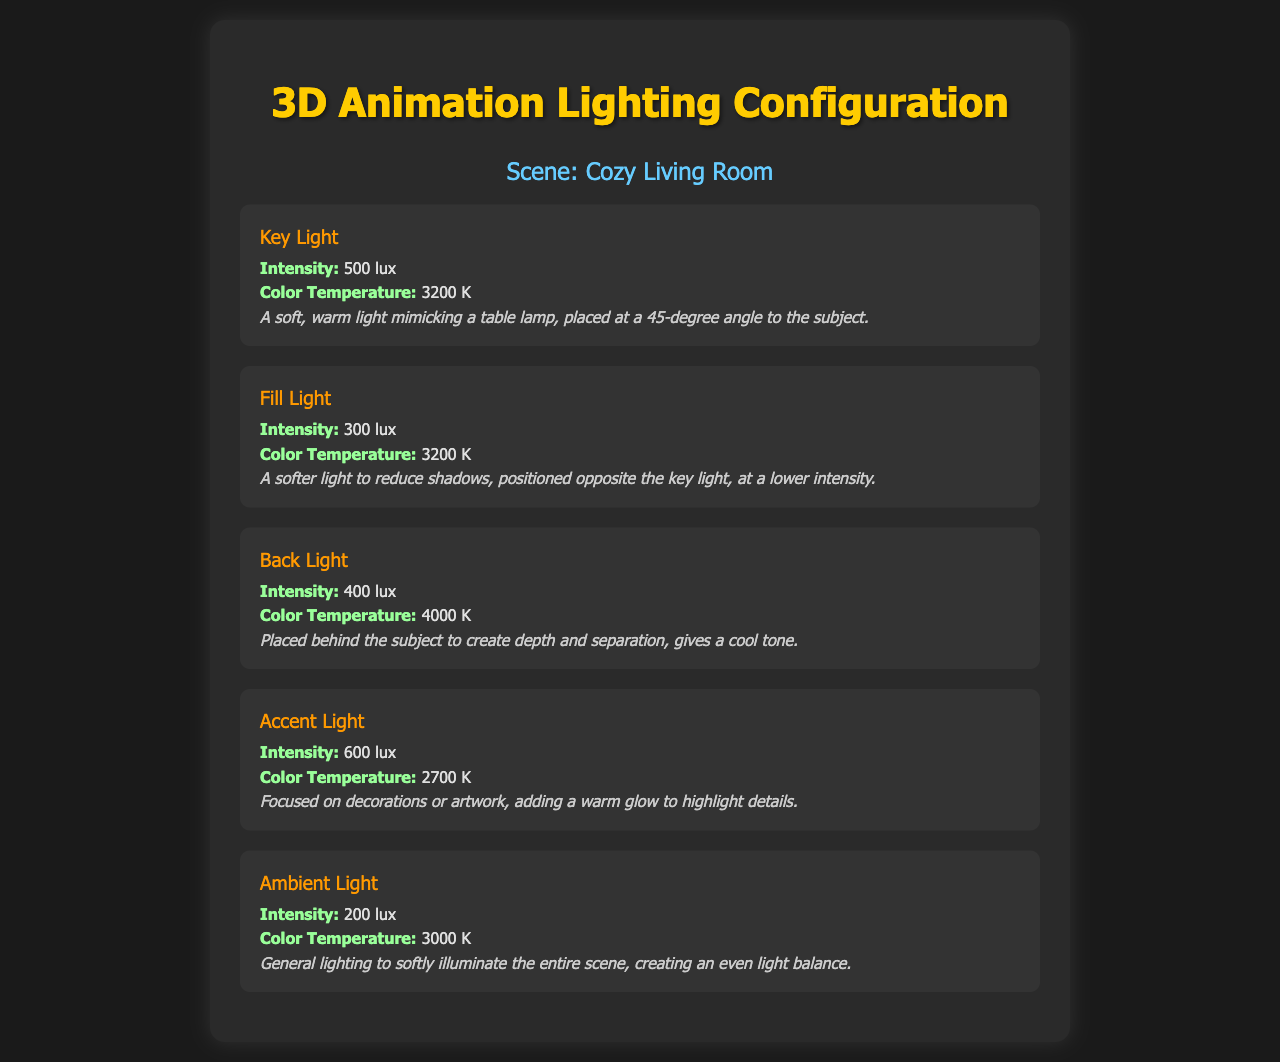what is the color temperature of the Key Light? The color temperature of the Key Light is provided in the document as 3200 K.
Answer: 3200 K what is the intensity of the Fill Light? The intensity of the Fill Light is stated as 300 lux in the document.
Answer: 300 lux where is the Back Light positioned? The document describes the Back Light as being placed behind the subject to create depth and separation.
Answer: Behind the subject what is the description of the Accent Light? The description states that the Accent Light is focused on decorations or artwork, adding a warm glow to highlight details.
Answer: Focused on decorations or artwork which light has the highest intensity? The document indicates that the Accent Light has the highest intensity, listed at 600 lux.
Answer: Accent Light what is the color temperature of the Ambient Light? The document specifies that the color temperature of the Ambient Light is 3000 K.
Answer: 3000 K how does the Fill Light function in the scene? According to the document, the Fill Light is used to reduce shadows and is positioned opposite the Key Light at a lower intensity.
Answer: Reduce shadows which light contributes a cool tone? The document indicates that the Back Light gives a cool tone.
Answer: Back Light what type of scene is described in the document? The document represents a scene described as a Cozy Living Room.
Answer: Cozy Living Room 